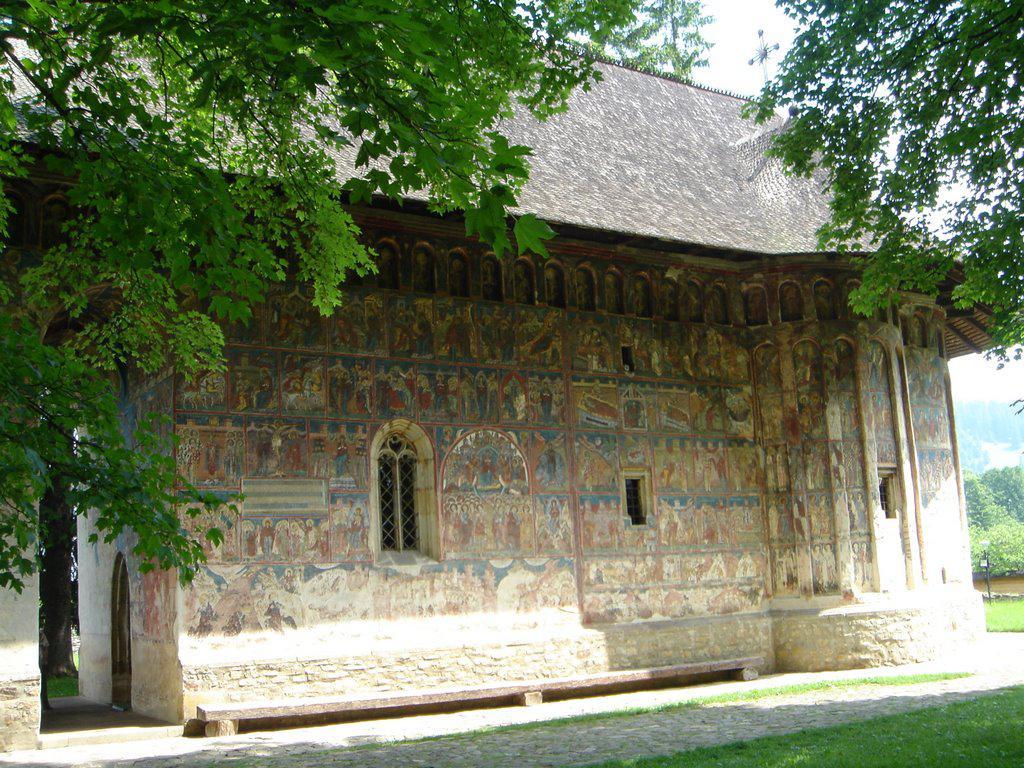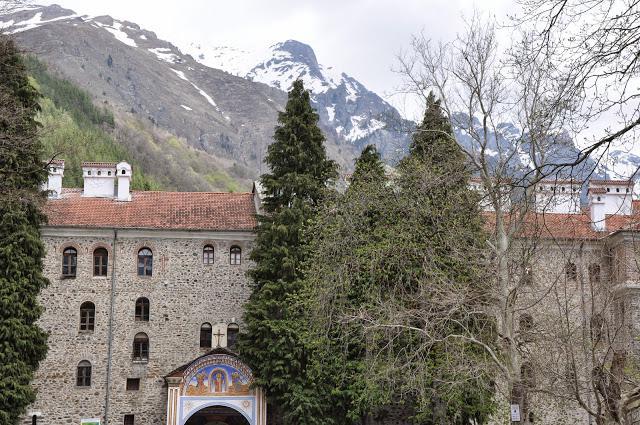The first image is the image on the left, the second image is the image on the right. Examine the images to the left and right. Is the description "At least one religious cross can be seen in one image." accurate? Answer yes or no. Yes. The first image is the image on the left, the second image is the image on the right. Considering the images on both sides, is "A stone path with a cauldron-type item leads to a grand entrance of a temple in one image." valid? Answer yes or no. No. 